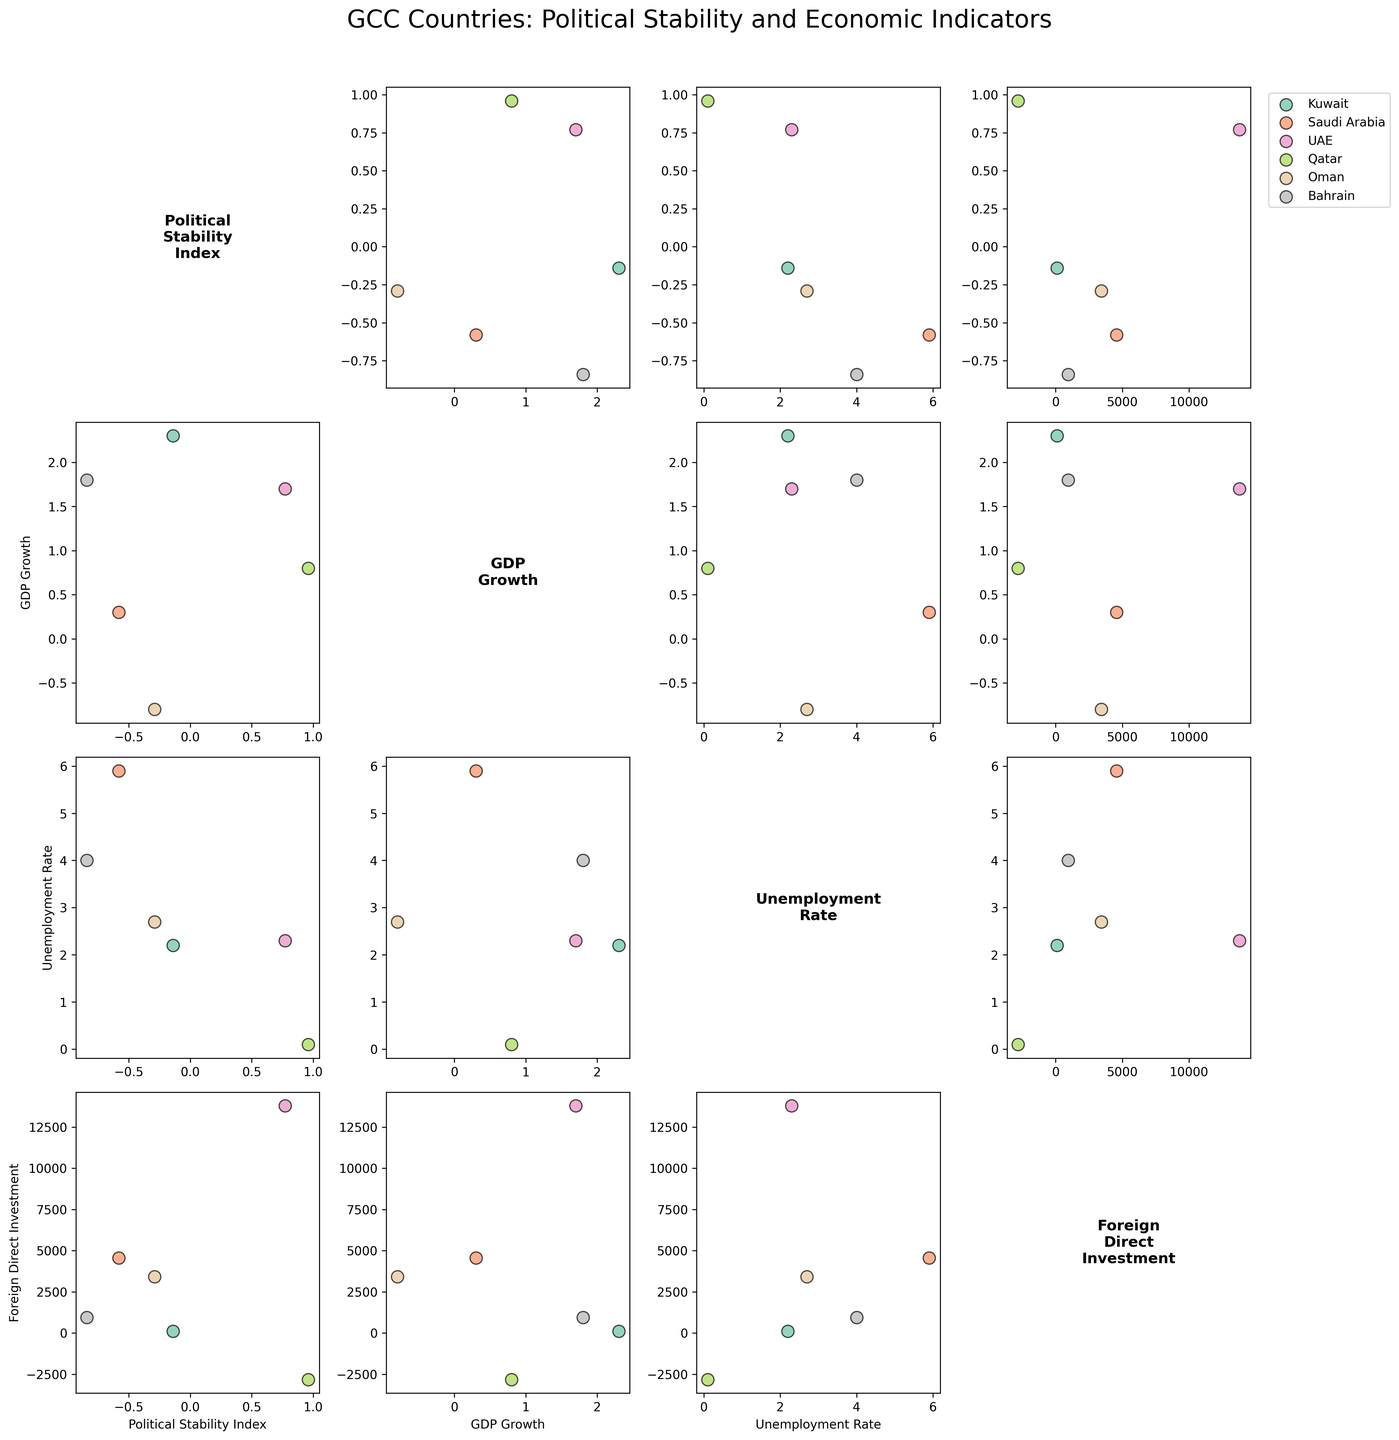What is the title of the figure? The title is located at the top of the figure and summarizes what the scatterplot matrix represents, which is Political Stability and Economic Indicators for GCC countries.
Answer: GCC Countries: Political Stability and Economic Indicators Which country's data point has the highest value for Foreign Direct Investment? By looking at the Foreign Direct Investment axis and comparing the values, the UAE has the highest Foreign Direct Investment value.
Answer: UAE How many variables are plotted in the scatterplot matrix? There are four variables indicated by the number of unique labels and axes present on the plot. They are Political Stability Index, GDP Growth, Unemployment Rate, and Foreign Direct Investment.
Answer: 4 Which country has the lowest Political Stability Index? By comparing the values in the Political Stability Index column across the axis, Bahrain has the lowest value.
Answer: Bahrain What is the relationship between Political Stability Index and Unemployment Rate for Qatar? Observing the scatterplot corresponding to Political Stability Index versus Unemployment Rate for Qatar reveals that Qatar has a high Political Stability Index and very low Unemployment Rate.
Answer: High Political Stability and very low Unemployment Rate What is the difference in the Foreign Direct Investment between Saudi Arabia and Qatar? The Foreign Direct Investment value for Saudi Arabia is 4563.3, and for Qatar, it is -2813.5. The difference can be calculated as 4563.3 - (-2813.5) = 7376.8.
Answer: 7376.8 Which country shows a negative GDP Growth and what is the corresponding Unemployment Rate? By observing the scatterplot matrix, the data point for Oman indicates a negative GDP Growth. The corresponding Unemployment Rate value can be checked in a scatterplot or axis label and is found to be 2.7.
Answer: Oman, 2.7 Which two countries have very close values in Political Stability Index? From the plotted data points for Political Stability Index, Kuwait and Oman have very close values. Kuwait's value is -0.14, and Oman's value is -0.29.
Answer: Kuwait and Oman 